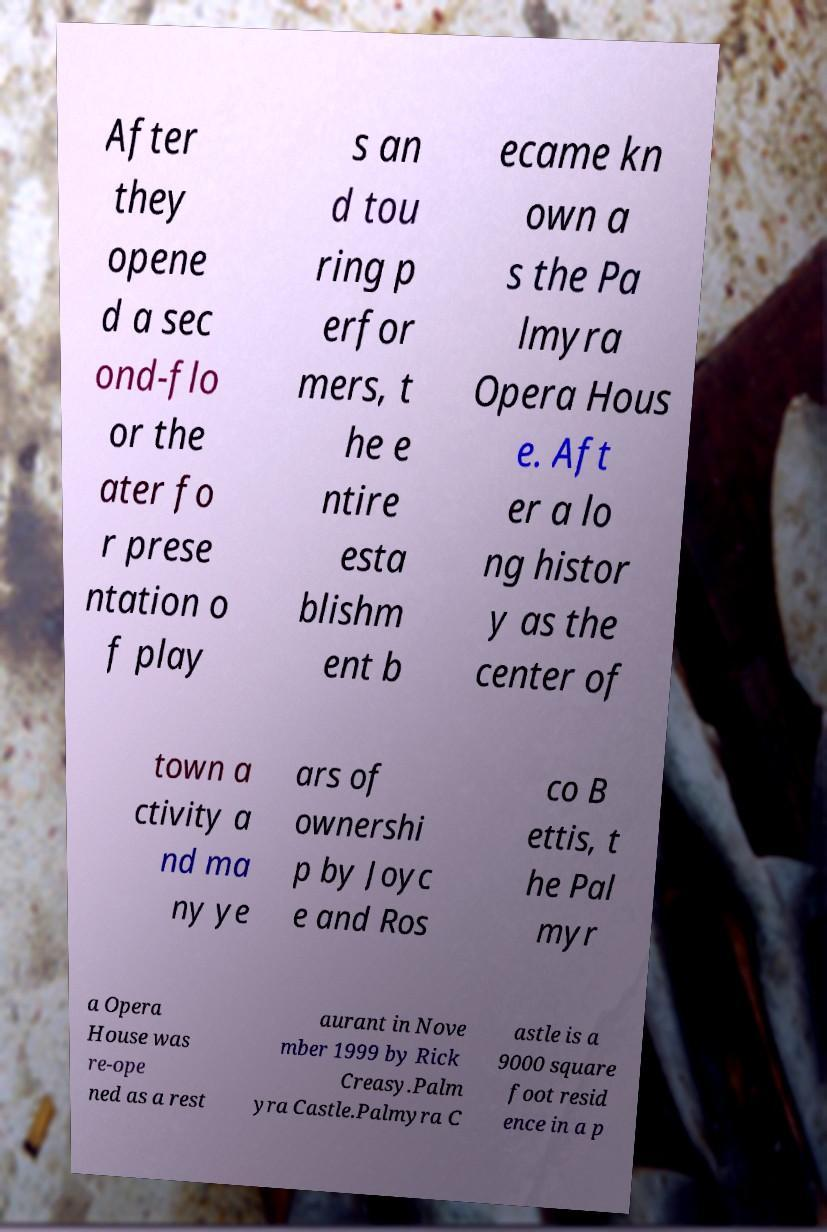Could you extract and type out the text from this image? After they opene d a sec ond-flo or the ater fo r prese ntation o f play s an d tou ring p erfor mers, t he e ntire esta blishm ent b ecame kn own a s the Pa lmyra Opera Hous e. Aft er a lo ng histor y as the center of town a ctivity a nd ma ny ye ars of ownershi p by Joyc e and Ros co B ettis, t he Pal myr a Opera House was re-ope ned as a rest aurant in Nove mber 1999 by Rick Creasy.Palm yra Castle.Palmyra C astle is a 9000 square foot resid ence in a p 